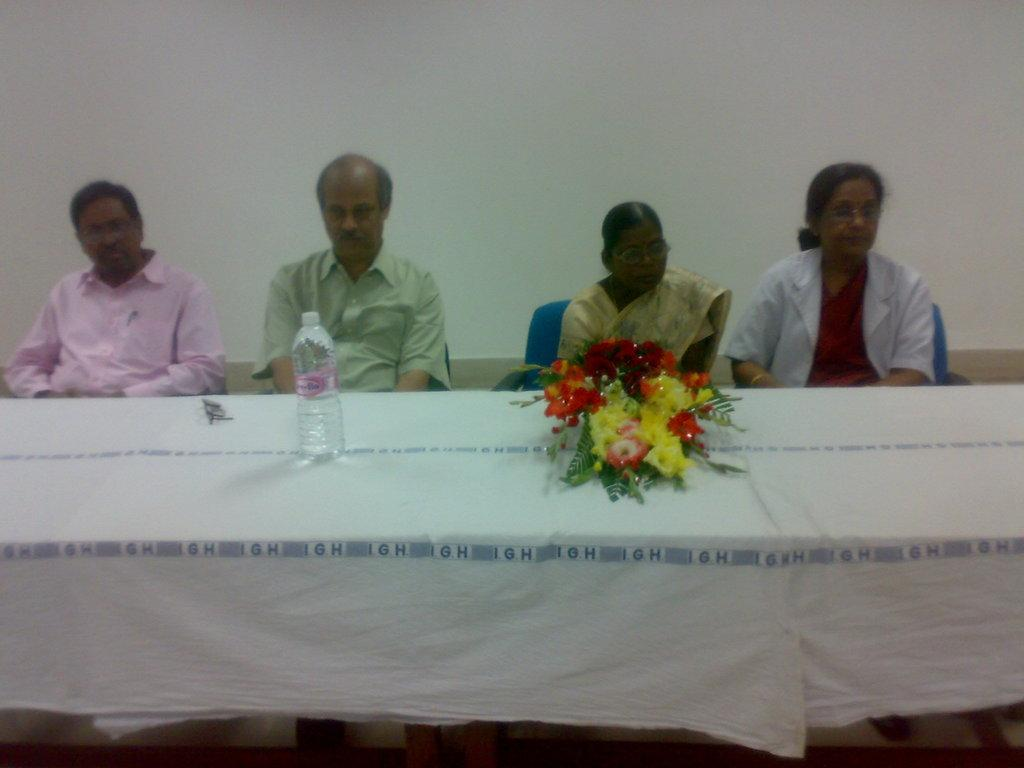How many people are in the image? There is a group of people in the image. What are the people doing in the image? The people are sitting on chairs. What is in front of the people? There is a table in front of the people. What can be found on the table? There is a water bottle on the table. What is another object present in the image? There is a flower book in the image. What can be seen in the background of the image? There is a wall in the background of the image. What type of bushes can be seen growing out of the drawer in the image? There are no bushes or drawers present in the image. 